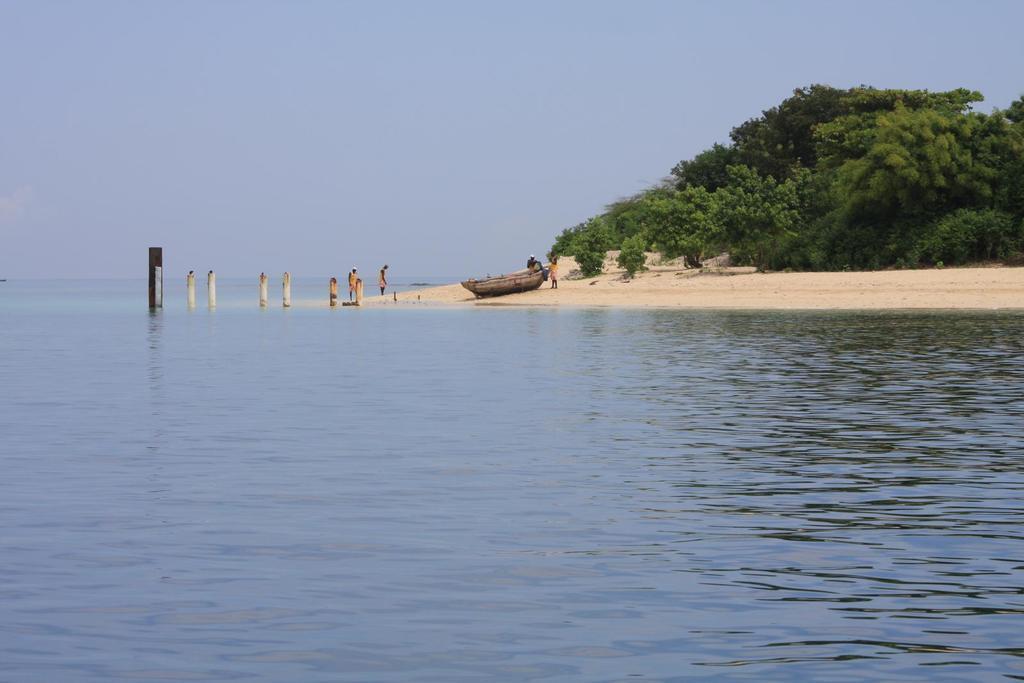Could you give a brief overview of what you see in this image? In this picture we can see water at the bottom, in the background there are some trees, we can see some people standing in the middle. we can also see a boat, there is the sky at the top of the picture. 